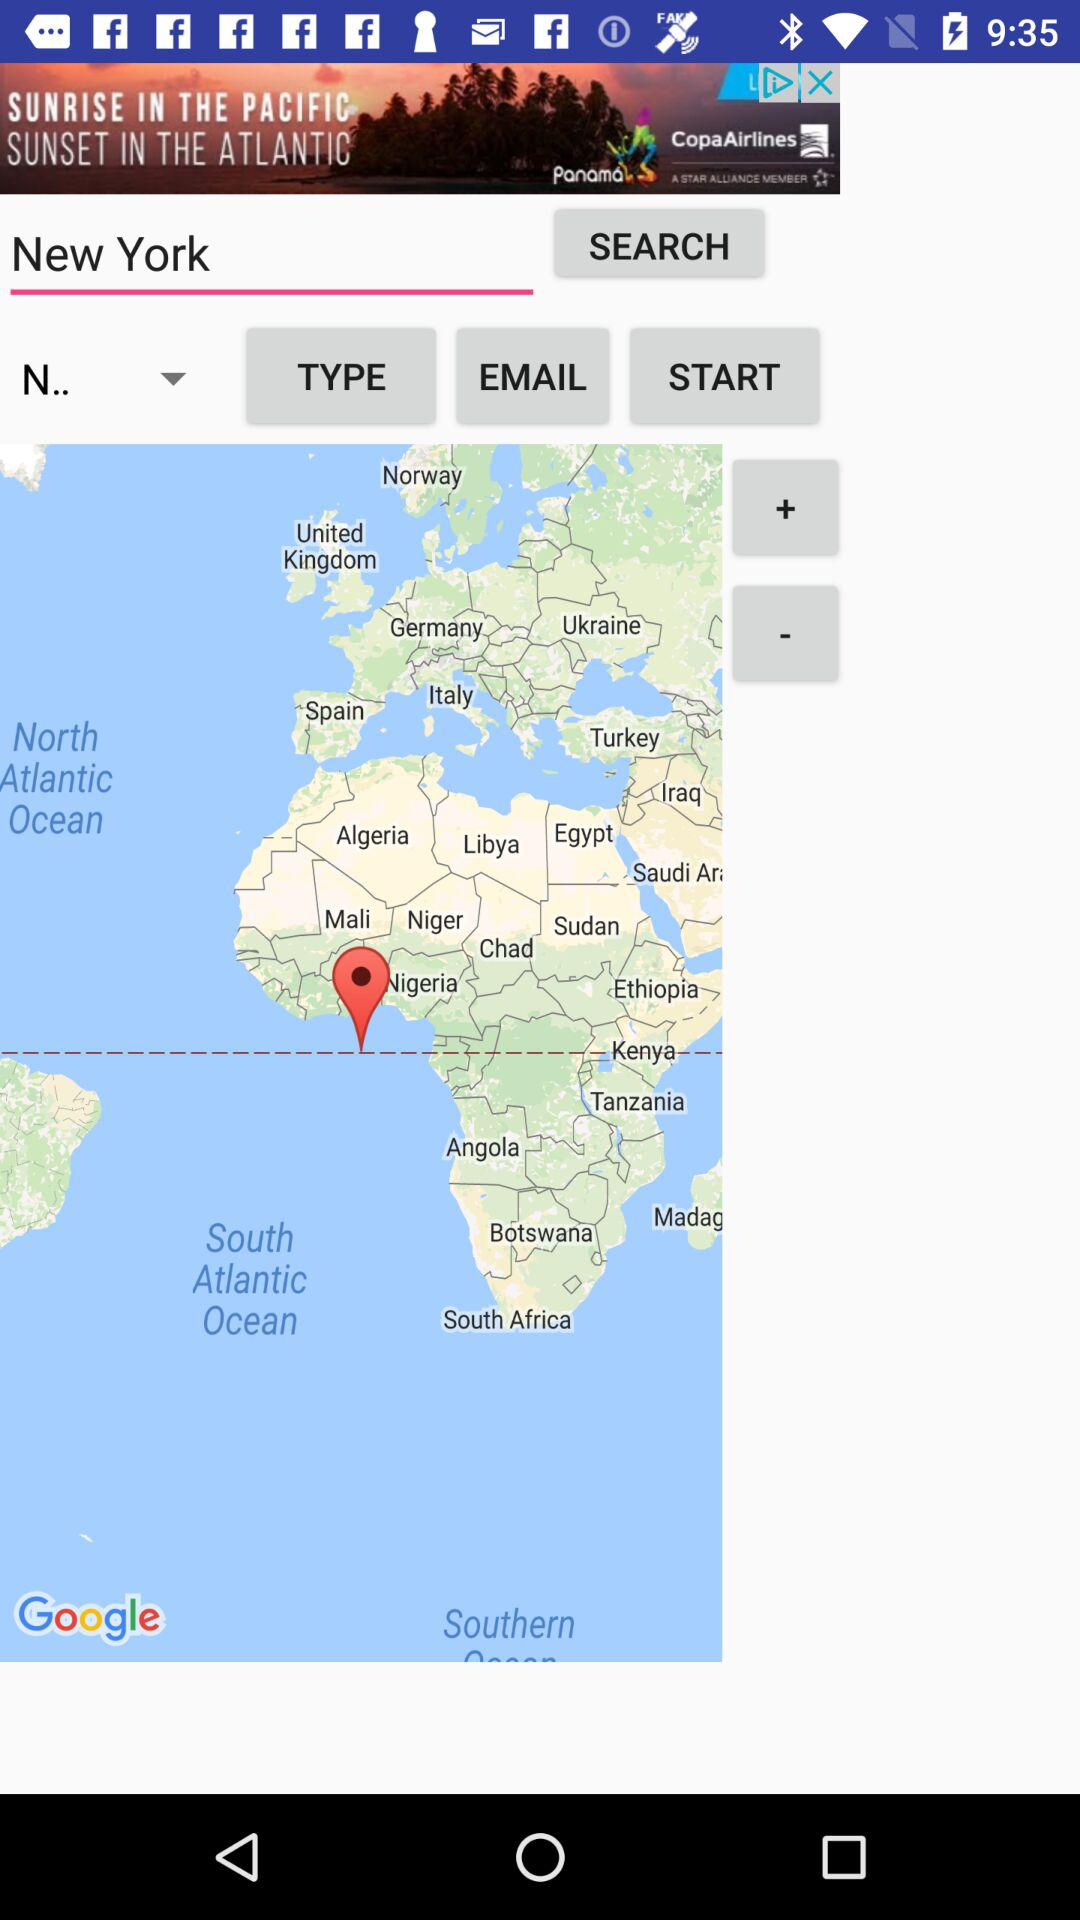For which country is the person searching? The person is searching for New York. 